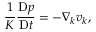Convert formula to latex. <formula><loc_0><loc_0><loc_500><loc_500>\frac { 1 } { K } \frac { D p } { D t } = - \nabla _ { k } v _ { k } ,</formula> 